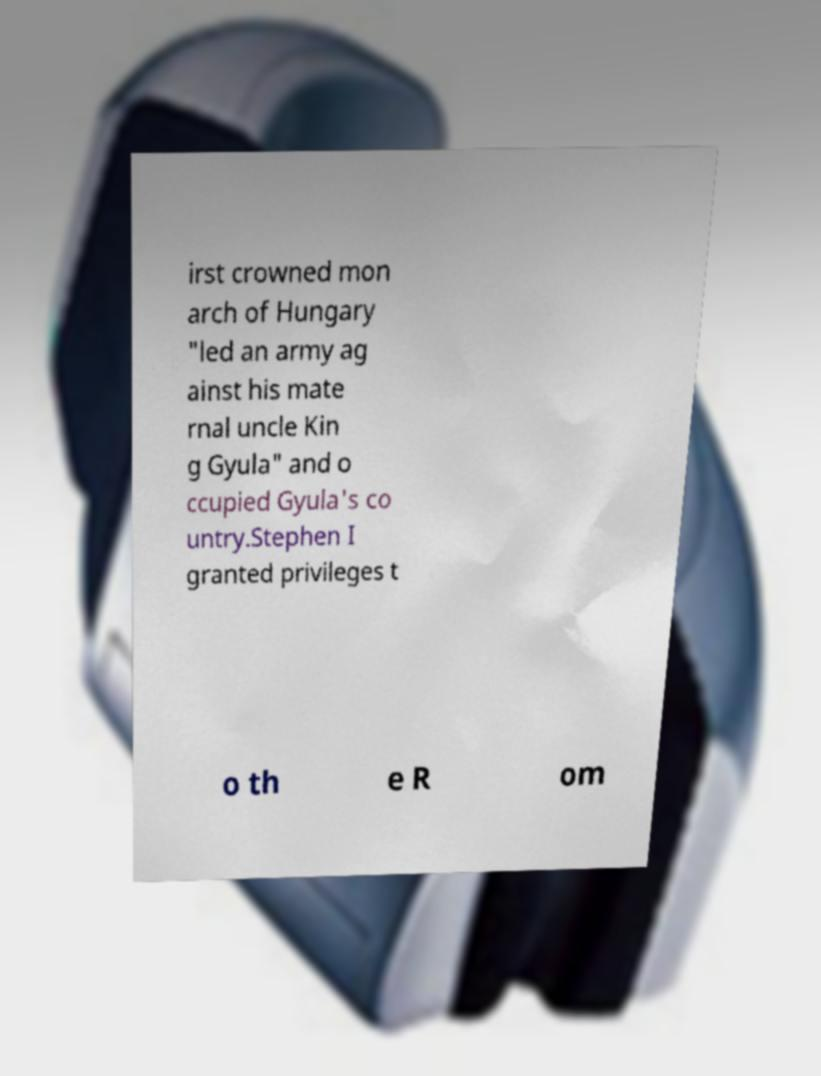Could you assist in decoding the text presented in this image and type it out clearly? irst crowned mon arch of Hungary "led an army ag ainst his mate rnal uncle Kin g Gyula" and o ccupied Gyula's co untry.Stephen I granted privileges t o th e R om 